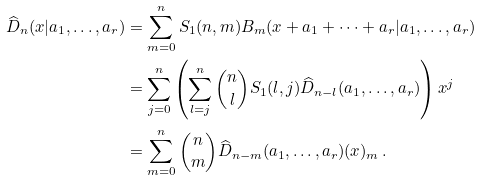<formula> <loc_0><loc_0><loc_500><loc_500>\widehat { D } _ { n } ( x | a _ { 1 } , \dots , a _ { r } ) & = \sum _ { m = 0 } ^ { n } S _ { 1 } ( n , m ) B _ { m } ( x + a _ { 1 } + \cdots + a _ { r } | a _ { 1 } , \dots , a _ { r } ) \\ & = \sum _ { j = 0 } ^ { n } \left ( \sum _ { l = j } ^ { n } \binom { n } { l } S _ { 1 } ( l , j ) \widehat { D } _ { n - l } ( a _ { 1 } , \dots , a _ { r } ) \right ) x ^ { j } \\ & = \sum _ { m = 0 } ^ { n } \binom { n } { m } \widehat { D } _ { n - m } ( a _ { 1 } , \dots , a _ { r } ) ( x ) _ { m } \, .</formula> 